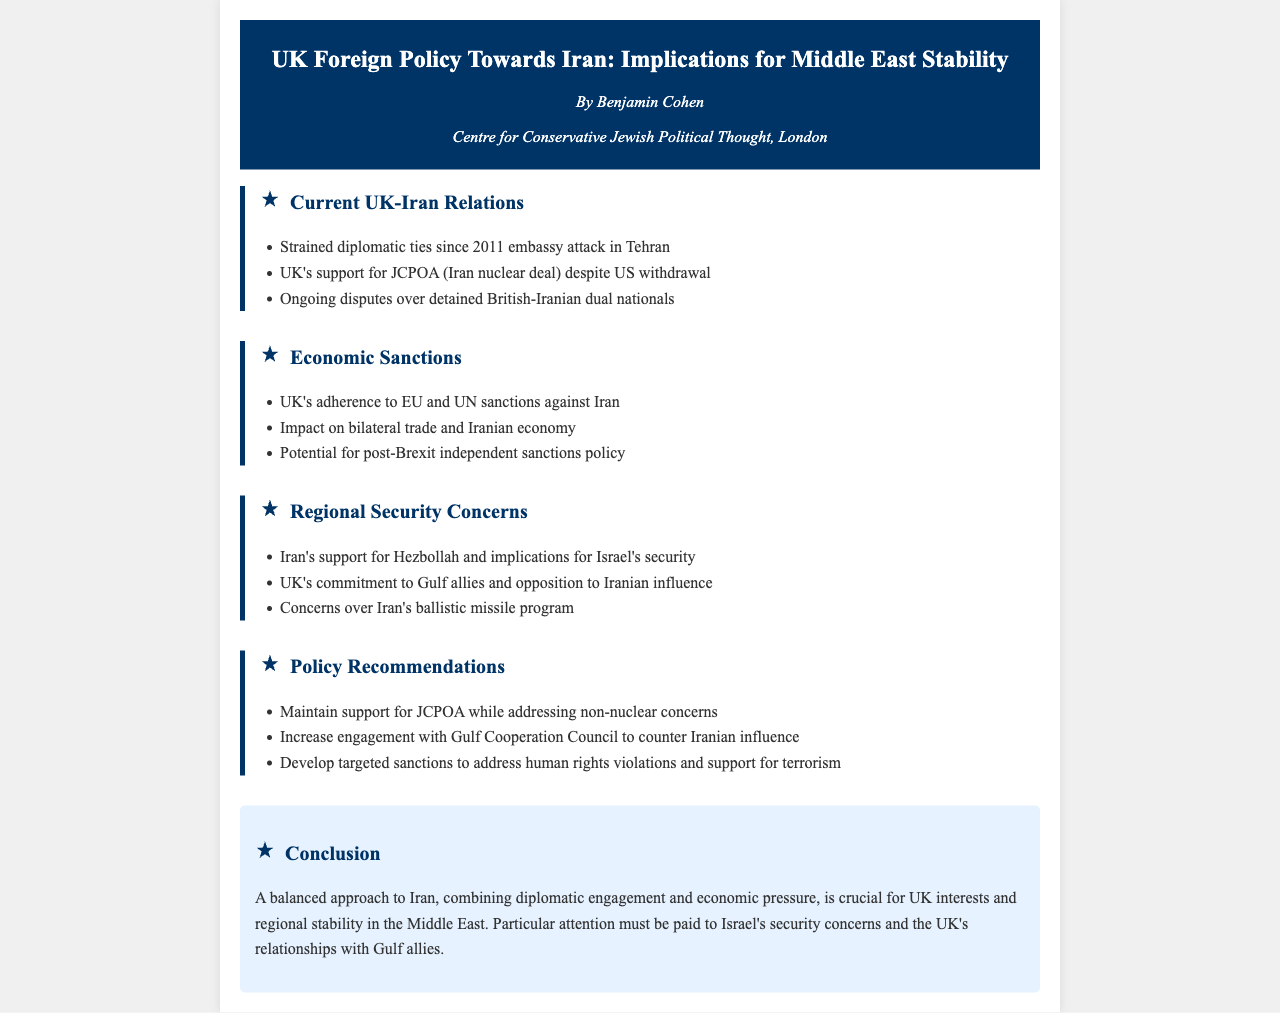What year did the embassy attack in Tehran occur? The document mentions that diplomatic ties between the UK and Iran have been strained since the embassy attack in 2011.
Answer: 2011 What is the UK's position on the JCPOA? The document states that the UK supports the JCPOA despite the US withdrawal from it.
Answer: Support Which organization’s influence is the UK committed to countering? The document specifies that the UK is committed to opposing Iranian influence, particularly in relation to Gulf allies.
Answer: Iranian influence What type of sanctions does the document recommend developing? The document suggests developing targeted sanctions to address human rights violations and support for terrorism.
Answer: Targeted sanctions What is one security concern related to Iran's military capabilities? The document lists concerns over Iran's ballistic missile program as a significant issue.
Answer: Ballistic missile program What is emphasized as crucial for UK interests in the Middle East? The conclusion highlights that a balanced approach combining diplomatic engagement and economic pressure is crucial for regional stability.
Answer: Balanced approach How does the document describe the UK's economic relationship with Iran? It indicates that there has been an impact on bilateral trade and the Iranian economy due to UK adherence to sanctions.
Answer: Impact on trade What is mentioned as an ongoing dispute involving the UK and Iran? The document notes ongoing disputes over detained British-Iranian dual nationals.
Answer: Detained dual nationals What is the author’s affiliation? The document lists the author as being part of the Centre for Conservative Jewish Political Thought, London.
Answer: Centre for Conservative Jewish Political Thought 